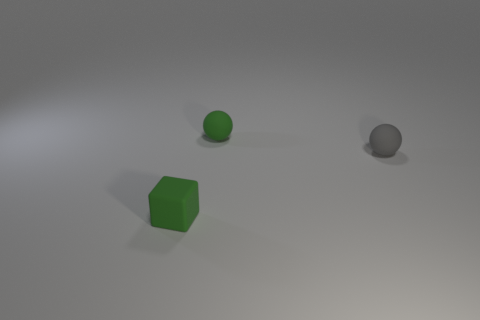Is the object that is behind the gray ball made of the same material as the tiny object in front of the gray matte ball?
Make the answer very short. Yes. How many big green metallic objects have the same shape as the gray object?
Give a very brief answer. 0. What material is the tiny thing that is the same color as the cube?
Offer a very short reply. Rubber. How many objects are either green cubes or green matte things behind the gray sphere?
Your answer should be compact. 2. What is the material of the small gray object?
Your response must be concise. Rubber. There is a small green object that is the same shape as the tiny gray matte object; what is it made of?
Your response must be concise. Rubber. There is a small matte thing that is right of the tiny green rubber thing behind the rubber cube; what color is it?
Offer a terse response. Gray. How many shiny objects are tiny green objects or spheres?
Offer a terse response. 0. Are the gray thing and the cube made of the same material?
Your answer should be very brief. Yes. What is the material of the small thing right of the tiny green thing behind the gray matte thing?
Keep it short and to the point. Rubber. 